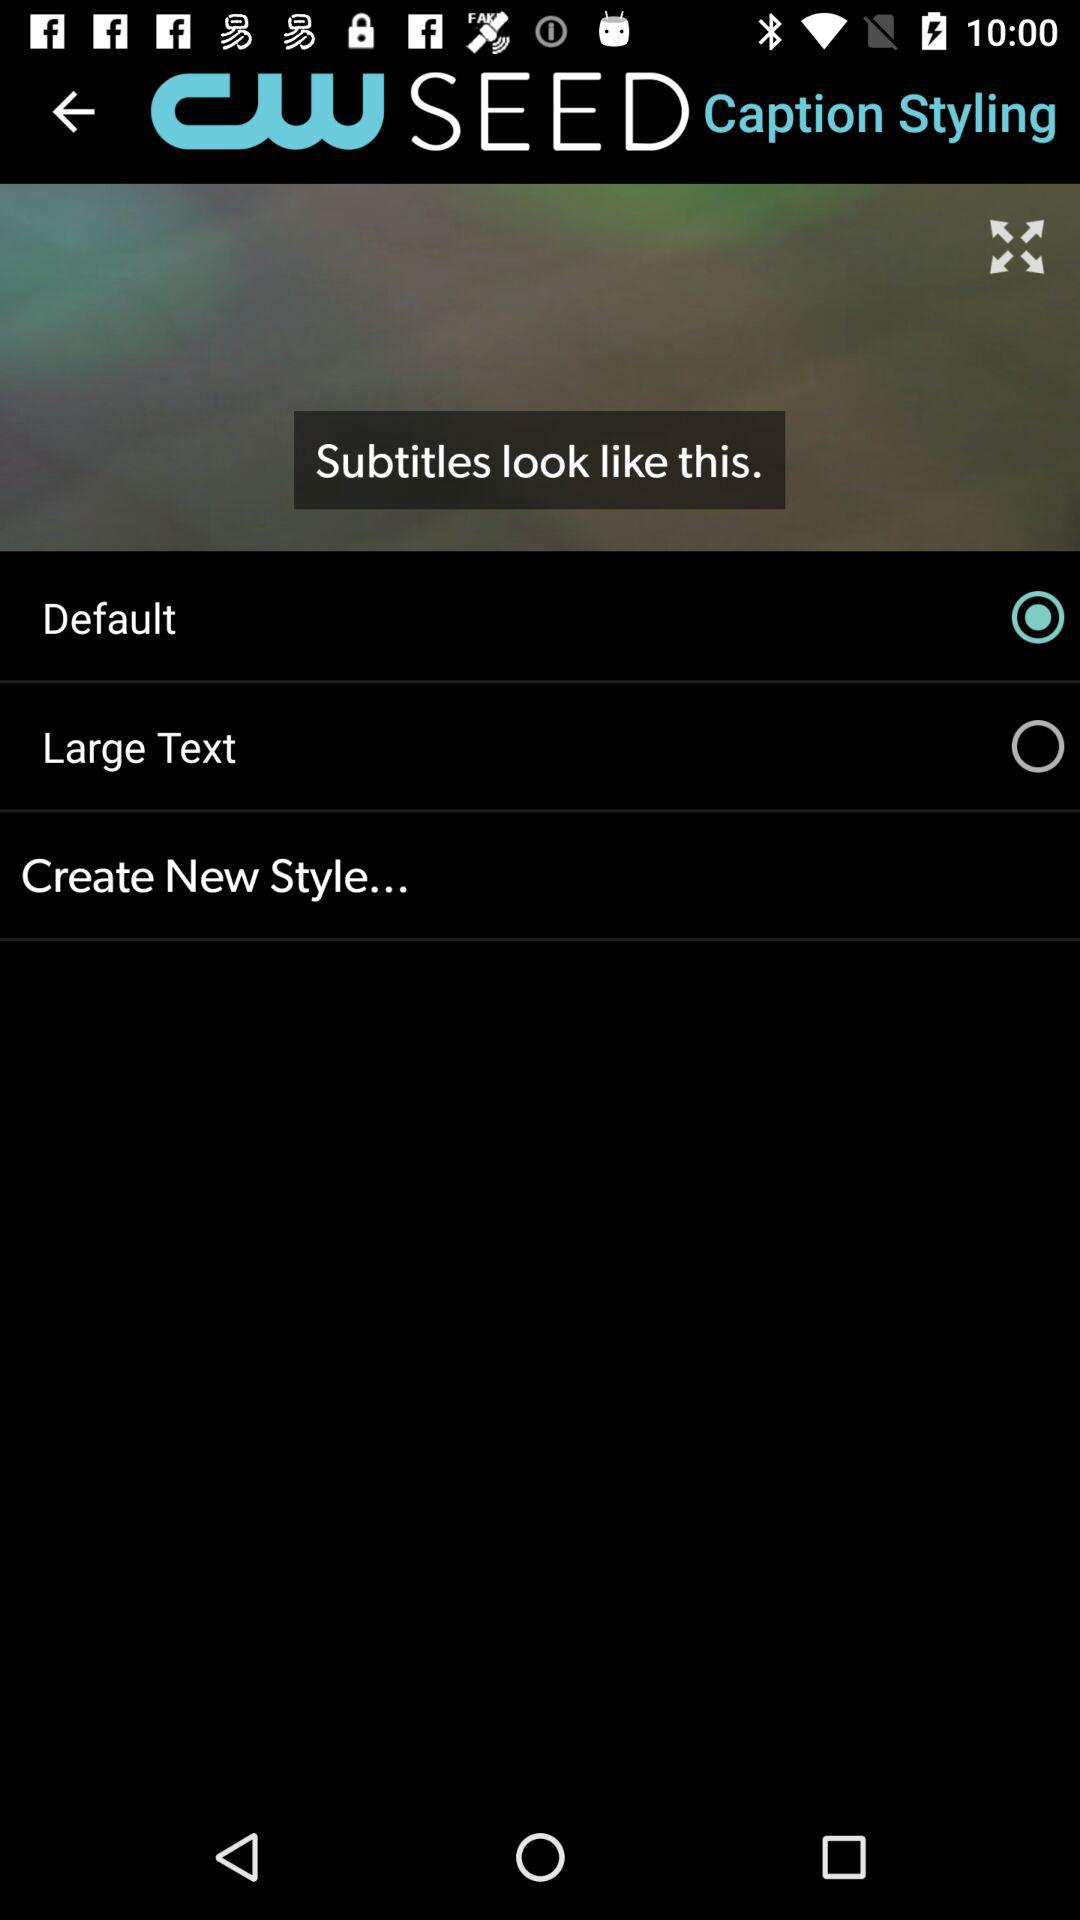When was this application developed?
When the provided information is insufficient, respond with <no answer>. <no answer> 